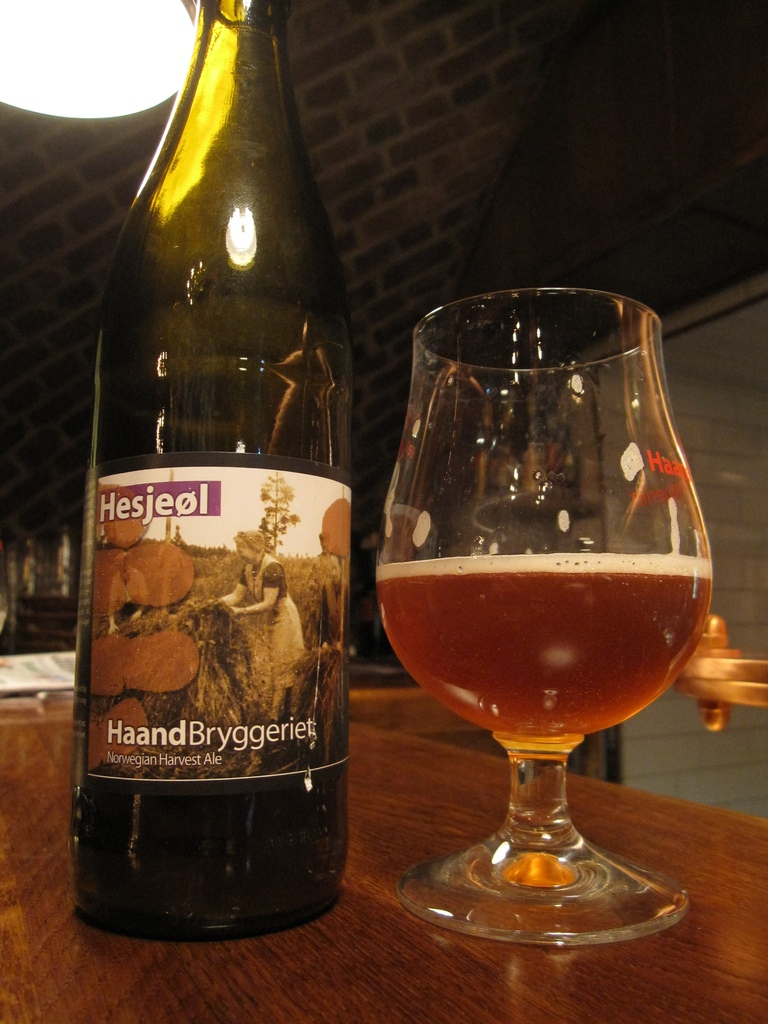Describe the atmosphere or setting in which the beer is placed. The beer is placed in a cozy, dimly lit setting that suggests a relaxed and intimate atmosphere, ideal for enjoying a specialty brew. 